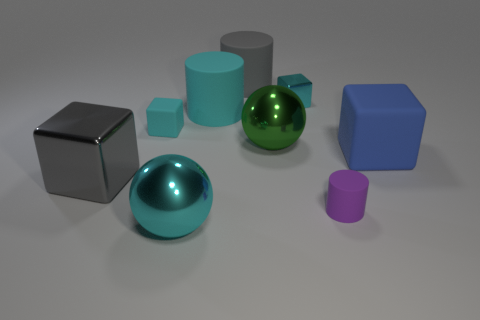Do the purple matte thing and the cyan metallic object that is behind the small purple cylinder have the same size?
Your response must be concise. Yes. What size is the cyan shiny thing that is the same shape as the large blue matte thing?
Provide a short and direct response. Small. There is a large gray object that is to the right of the shiny ball in front of the gray metal cube; what number of cylinders are in front of it?
Provide a succinct answer. 2. How many cubes are either big gray matte objects or small cyan things?
Offer a terse response. 2. There is a ball in front of the big cube on the left side of the tiny block to the left of the green ball; what color is it?
Provide a succinct answer. Cyan. What number of other things are there of the same size as the gray matte cylinder?
Keep it short and to the point. 5. Is there any other thing that is the same shape as the large cyan matte thing?
Ensure brevity in your answer.  Yes. What is the color of the other large thing that is the same shape as the green object?
Your answer should be very brief. Cyan. There is another small cylinder that is made of the same material as the cyan cylinder; what color is it?
Your response must be concise. Purple. Are there the same number of big gray matte things that are left of the big shiny block and yellow metallic things?
Your answer should be compact. Yes. 